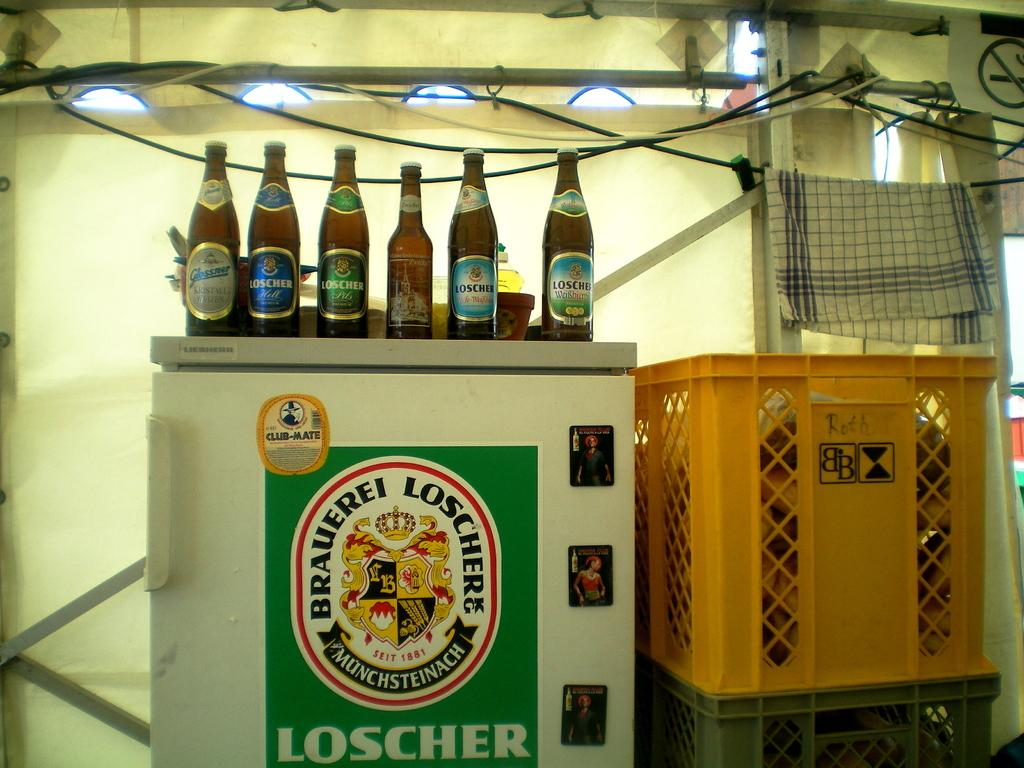<image>
Offer a succinct explanation of the picture presented. A row of bottles sit on top of a refrigerator with Loscher on the door. 